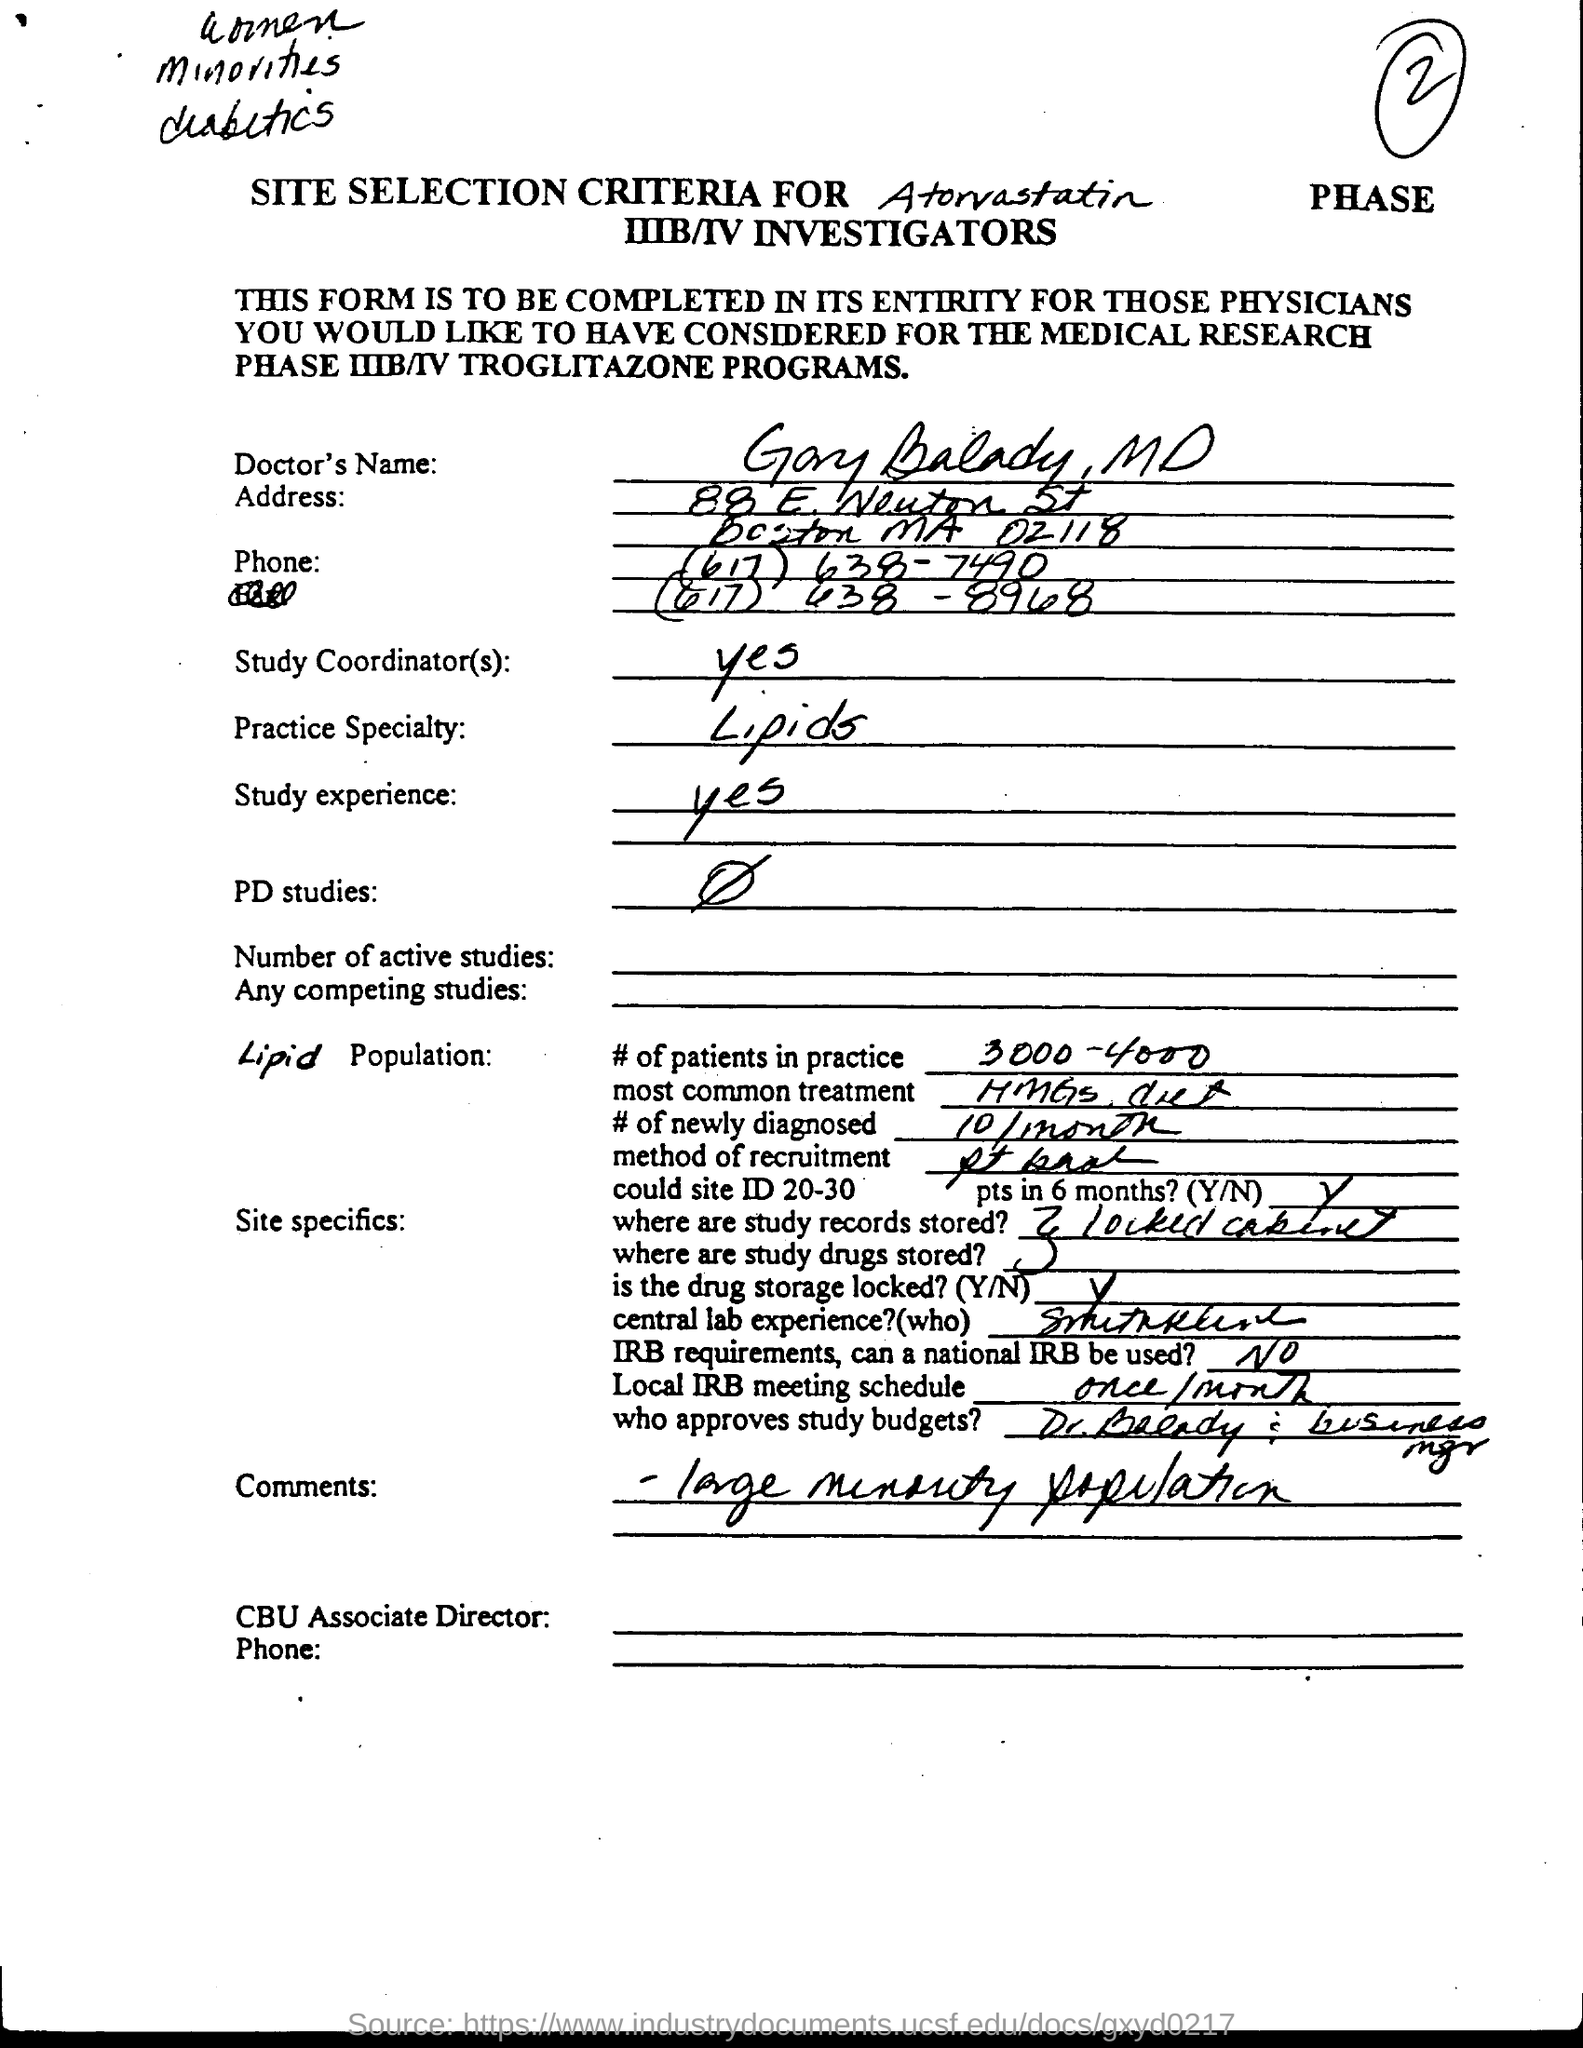List a handful of essential elements in this visual. The number of newly diagnosed cases per month is 10. The study records and study drugs are stored in a locked cabinet. The practice specialty is lipid-related work. The local IRB meeting is scheduled to occur once per month. 